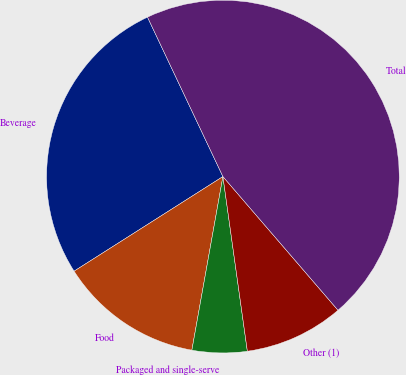Convert chart to OTSL. <chart><loc_0><loc_0><loc_500><loc_500><pie_chart><fcel>Beverage<fcel>Food<fcel>Packaged and single-serve<fcel>Other (1)<fcel>Total<nl><fcel>26.98%<fcel>13.17%<fcel>5.03%<fcel>9.1%<fcel>45.72%<nl></chart> 